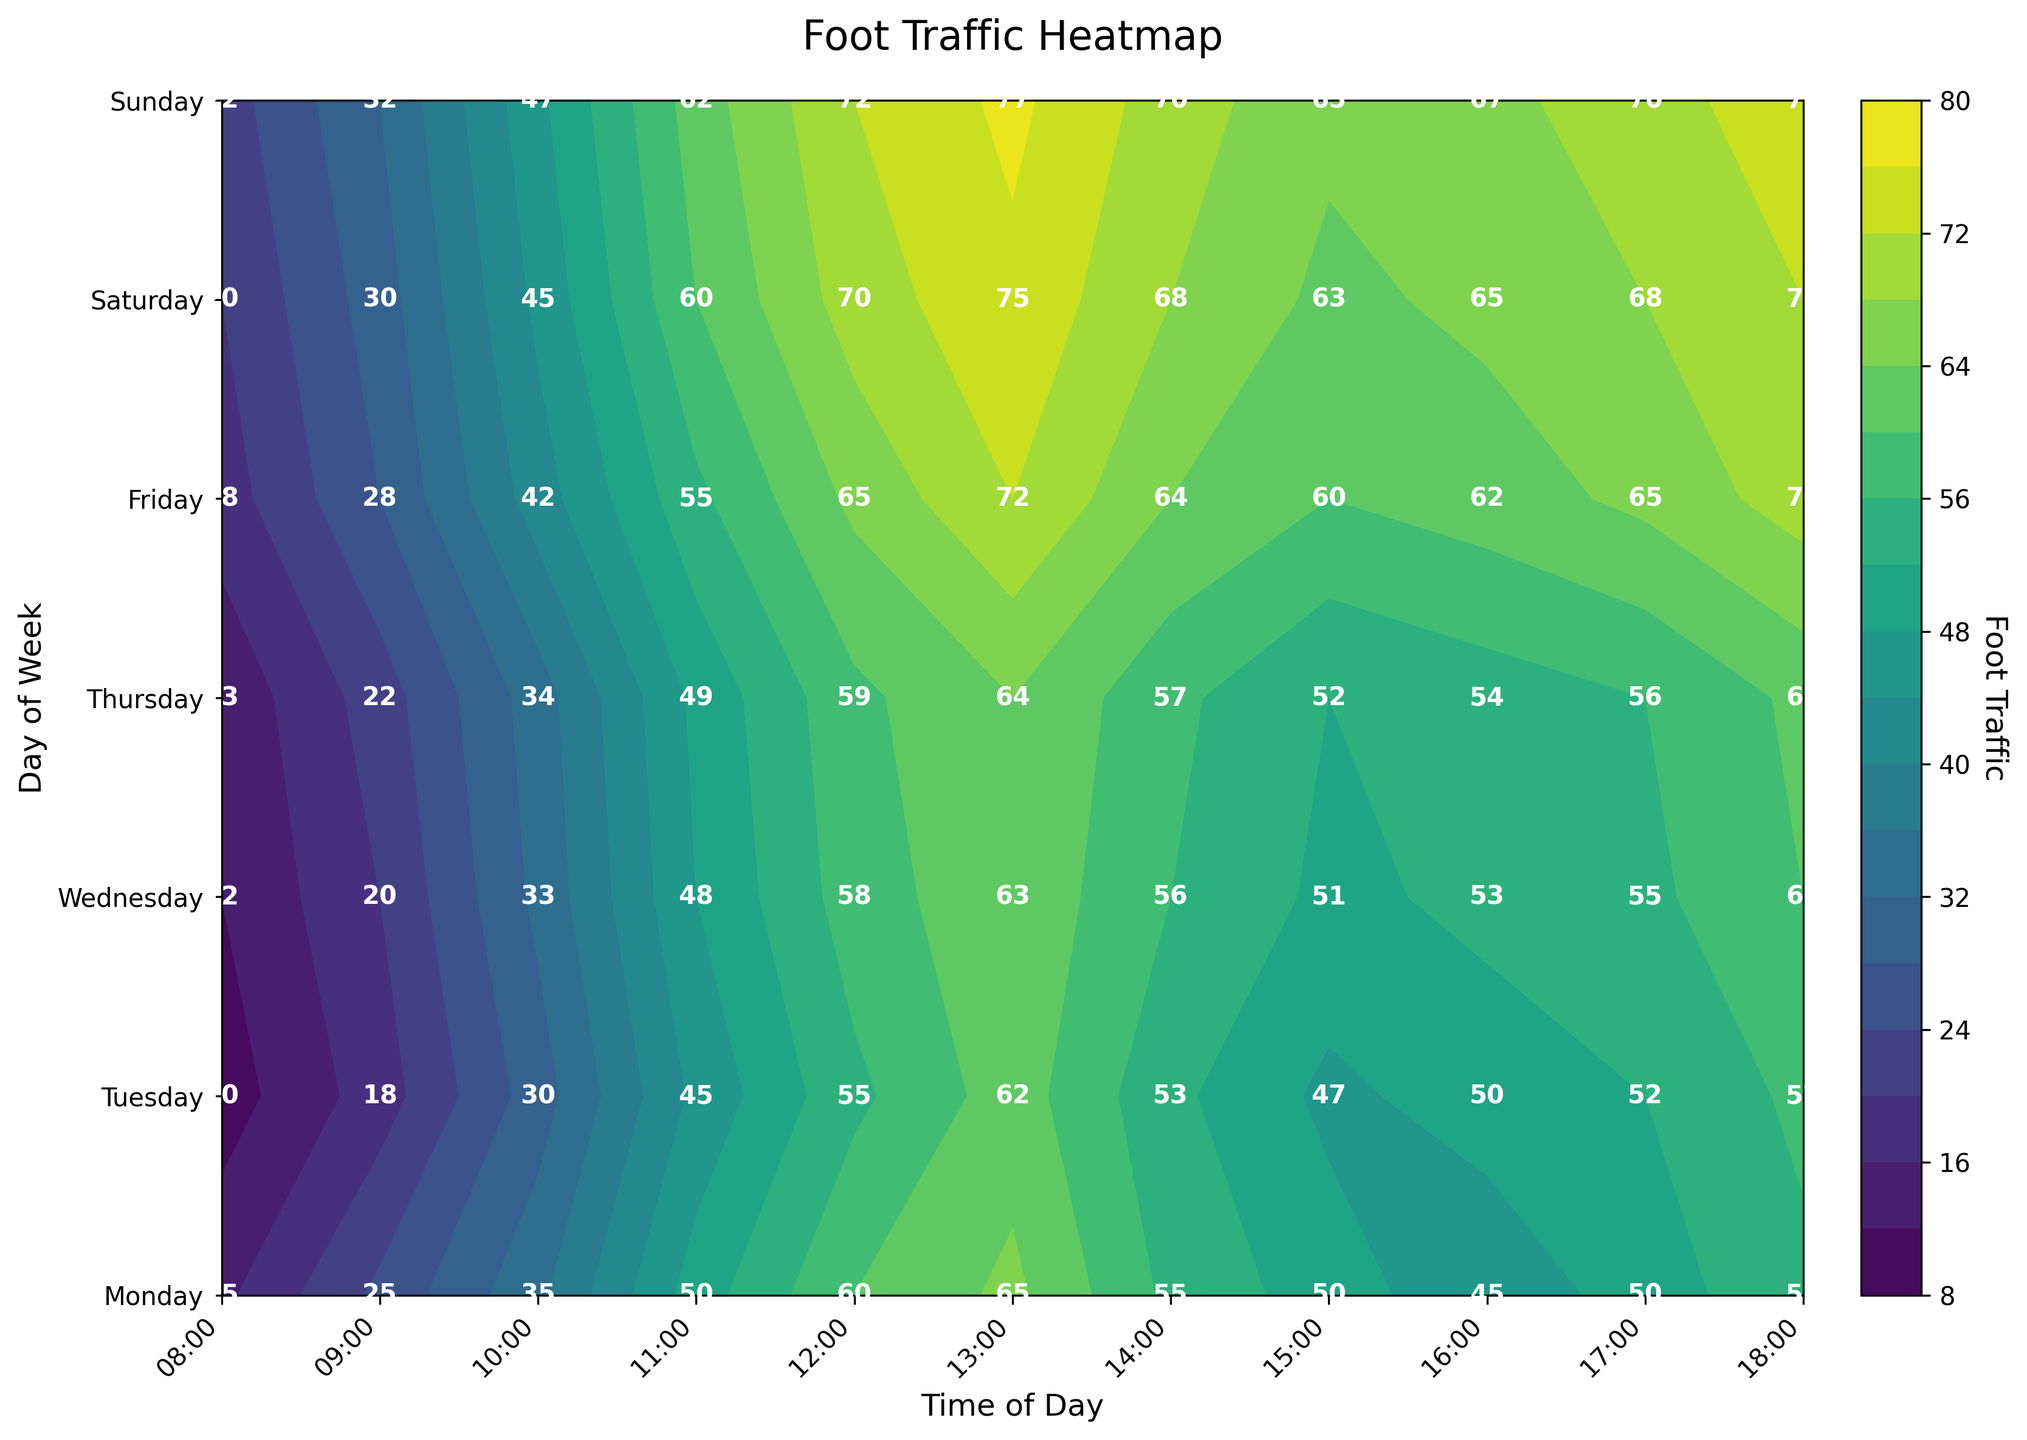What is the peak foot traffic value shown in the plot? Identify the darkest region in the contour plot, which corresponds to the highest foot traffic value, and refer to the color bar for the numerical value. The label indicates that this value is 77.
Answer: 77 At what time of day does foot traffic start to increase on Sundays? Look at the contour plot specifically for Sunday. Foot traffic starts low in the earlier hours. Notice the increase starting at 10:00, indicated by the shift in contour color.
Answer: 10:00 Which day has the lowest foot traffic at 08:00? Compare the color and label of the contour at 08:00 across all days. The lowest value is recorded on Tuesday with the label indicating a foot traffic of 10.
Answer: Tuesday What is the trend of foot traffic on Fridays from morning to evening? Observe the changes in contour color for Friday from 08:00 to 18:00. The color goes from lighter to darker, showing a general increasing trend in foot traffic throughout the day.
Answer: Increasing How does the foot traffic at 15:00 on Saturday compare to that on Wednesday? Check the contour labels for 15:00 on both days. Saturday shows a value of 63 and Wednesday shows a value of 51. Thus, the foot traffic is higher on Saturday.
Answer: Higher What is the average foot traffic on Mondays? Sum up the foot traffic values for Monday (15 + 25 + 35 + 50 + 60 + 65 + 55 + 50 + 45 + 50 + 55) and divide by the number of observations (11). The total sum is 505, so the average is 505/11.
Answer: 45.91 Which time of day shows the highest variation in foot traffic throughout the week? Evaluate the spread of values in each time slot. At 18:00, the values range widely from 55 on Monday to 75 on Sunday, showing the highest variation.
Answer: 18:00 On which day does foot traffic hit 50 the earliest in the day? On the contour plot, find the earliest time of day where the color corresponds to a value of 50. Monday shows 50 at 11:00, which is earlier than other days.
Answer: Monday By how much does foot traffic at 13:00 on Thursday surpass that on Tuesday? Foot traffic at 13:00 on Thursday is 64, and on Tuesday it is 62. The difference between these values is 64 - 62.
Answer: 2 What pattern can be observed in the weekend foot traffic compared to weekdays? Compare the contour colors and labels for weekend (Saturday and Sunday) versus weekdays. Weekends show consistently higher foot traffic, especially in the afternoon times (14:00 to 18:00).
Answer: Higher on weekends 